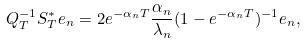Convert formula to latex. <formula><loc_0><loc_0><loc_500><loc_500>Q _ { T } ^ { - 1 } S ^ { * } _ { T } e _ { n } = 2 e ^ { - \alpha _ { n } T } \frac { \alpha _ { n } } { \lambda _ { n } } ( 1 - e ^ { - \alpha _ { n } T } ) ^ { - 1 } e _ { n } ,</formula> 